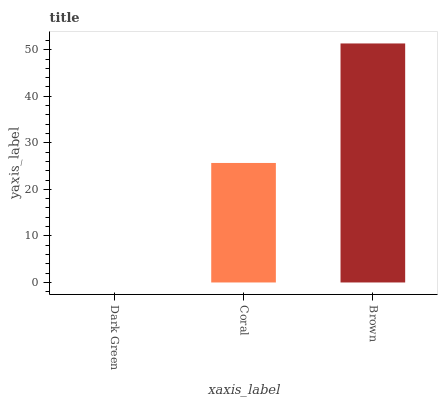Is Dark Green the minimum?
Answer yes or no. Yes. Is Brown the maximum?
Answer yes or no. Yes. Is Coral the minimum?
Answer yes or no. No. Is Coral the maximum?
Answer yes or no. No. Is Coral greater than Dark Green?
Answer yes or no. Yes. Is Dark Green less than Coral?
Answer yes or no. Yes. Is Dark Green greater than Coral?
Answer yes or no. No. Is Coral less than Dark Green?
Answer yes or no. No. Is Coral the high median?
Answer yes or no. Yes. Is Coral the low median?
Answer yes or no. Yes. Is Dark Green the high median?
Answer yes or no. No. Is Dark Green the low median?
Answer yes or no. No. 